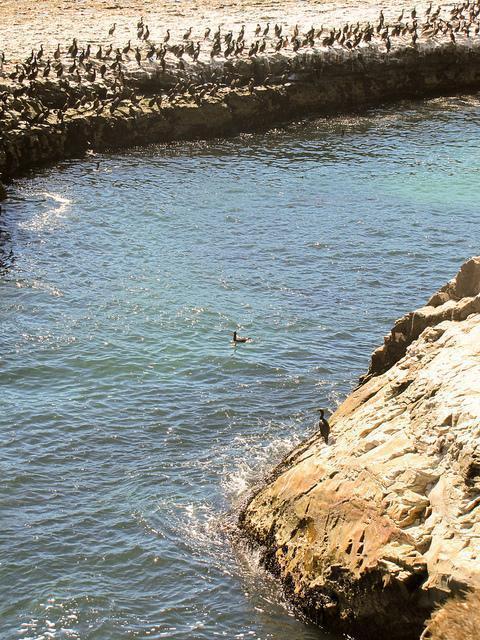What surface are all the birds standing on next to the big river?
Indicate the correct response by choosing from the four available options to answer the question.
Options: Stone, dirt, wood, grass. Stone. What is usually found inside of the large blue item?
Make your selection from the four choices given to correctly answer the question.
Options: Flowers, soda, beef, fish. Fish. 